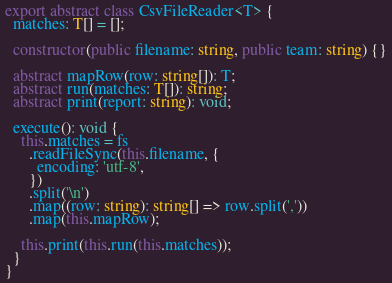<code> <loc_0><loc_0><loc_500><loc_500><_TypeScript_>
export abstract class CsvFileReader<T> {
  matches: T[] = [];

  constructor(public filename: string, public team: string) {}

  abstract mapRow(row: string[]): T;
  abstract run(matches: T[]): string;
  abstract print(report: string): void;

  execute(): void {
    this.matches = fs
      .readFileSync(this.filename, {
        encoding: 'utf-8',
      })
      .split('\n')
      .map((row: string): string[] => row.split(','))
      .map(this.mapRow);

    this.print(this.run(this.matches));
  }
}
</code> 